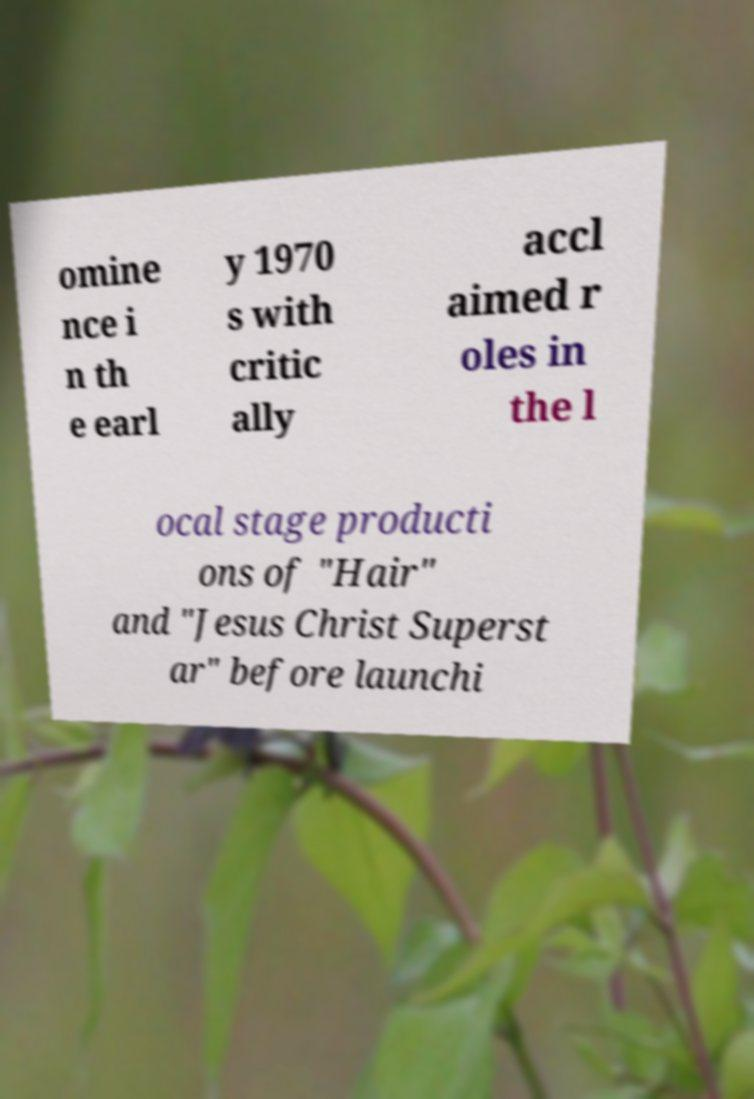Could you extract and type out the text from this image? omine nce i n th e earl y 1970 s with critic ally accl aimed r oles in the l ocal stage producti ons of "Hair" and "Jesus Christ Superst ar" before launchi 